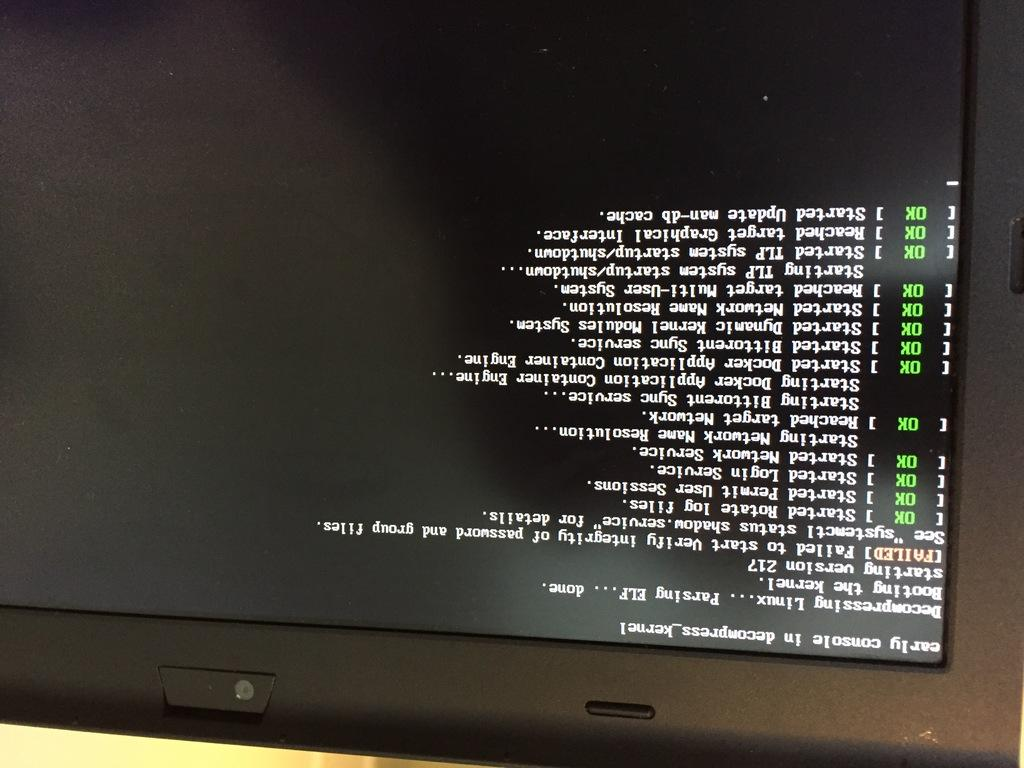<image>
Give a short and clear explanation of the subsequent image. An upside down black computer screen indicates that the early console is in decompress. 